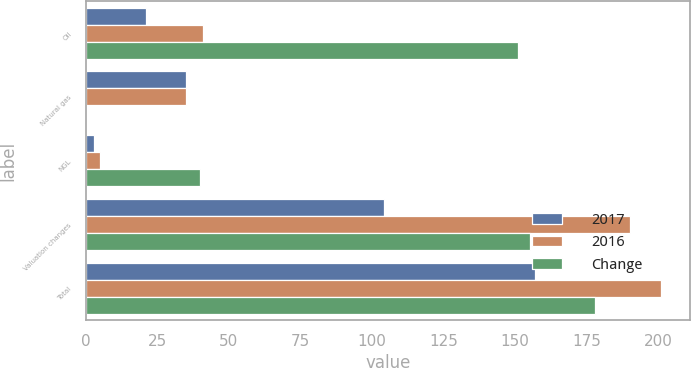Convert chart to OTSL. <chart><loc_0><loc_0><loc_500><loc_500><stacked_bar_chart><ecel><fcel>Oil<fcel>Natural gas<fcel>NGL<fcel>Valuation changes<fcel>Total<nl><fcel>2017<fcel>21<fcel>35<fcel>3<fcel>104<fcel>157<nl><fcel>2016<fcel>41<fcel>35<fcel>5<fcel>190<fcel>201<nl><fcel>Change<fcel>151<fcel>0<fcel>40<fcel>155<fcel>178<nl></chart> 